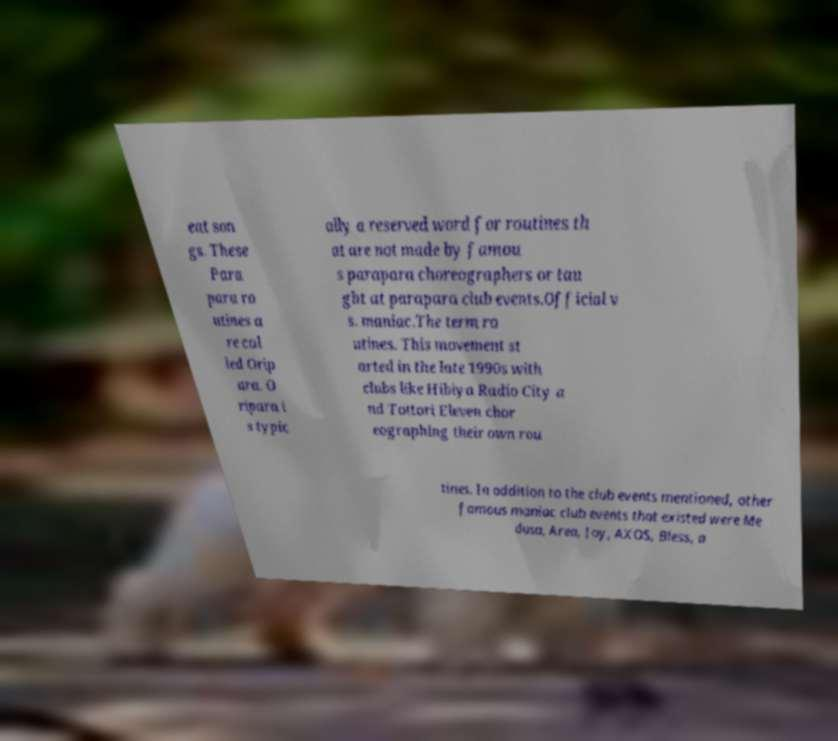There's text embedded in this image that I need extracted. Can you transcribe it verbatim? eat son gs. These Para para ro utines a re cal led Orip ara. O ripara i s typic ally a reserved word for routines th at are not made by famou s parapara choreographers or tau ght at parapara club events.Official v s. maniac.The term ro utines. This movement st arted in the late 1990s with clubs like Hibiya Radio City a nd Tottori Eleven chor eographing their own rou tines. In addition to the club events mentioned, other famous maniac club events that existed were Me dusa, Area, Joy, AXOS, Bless, a 